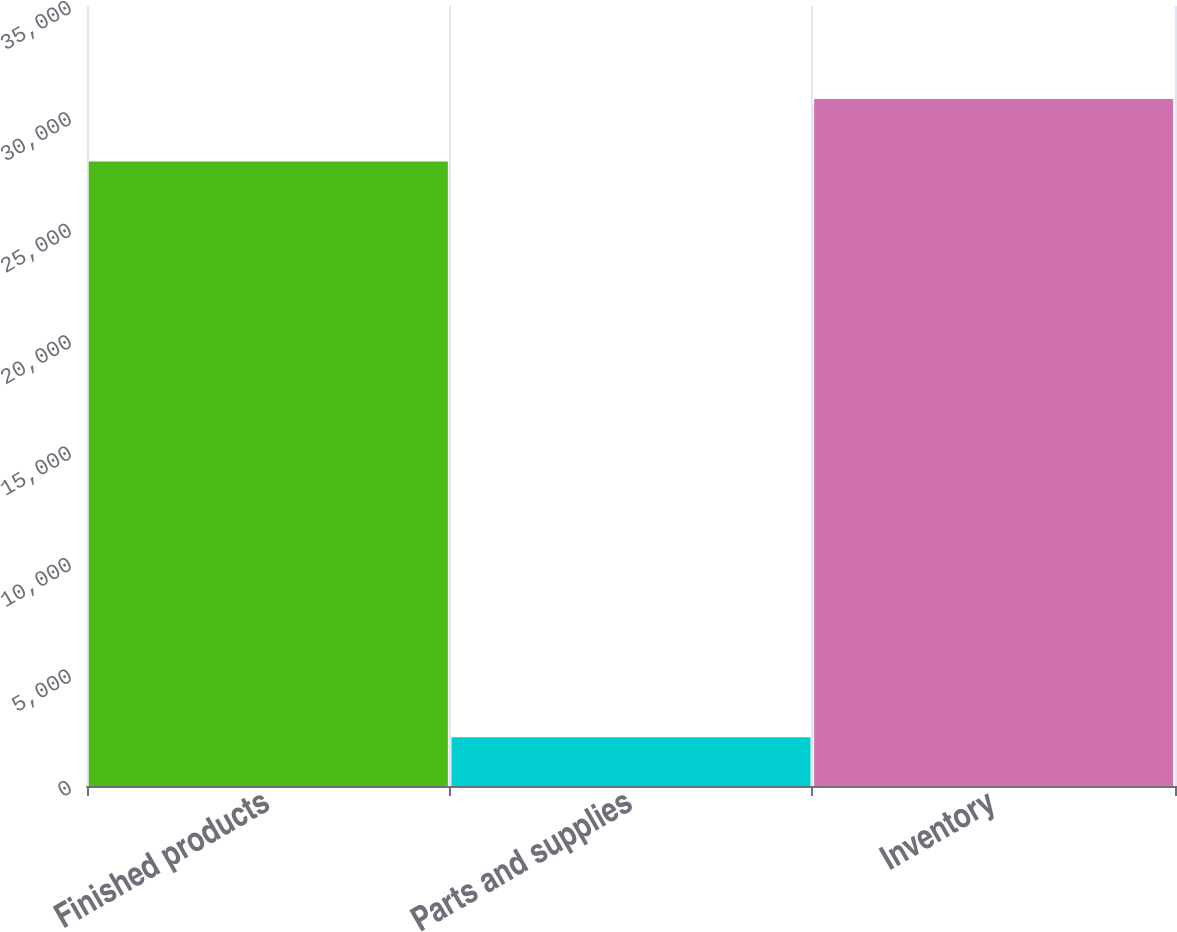Convert chart to OTSL. <chart><loc_0><loc_0><loc_500><loc_500><bar_chart><fcel>Finished products<fcel>Parts and supplies<fcel>Inventory<nl><fcel>28026<fcel>2192<fcel>30828.6<nl></chart> 